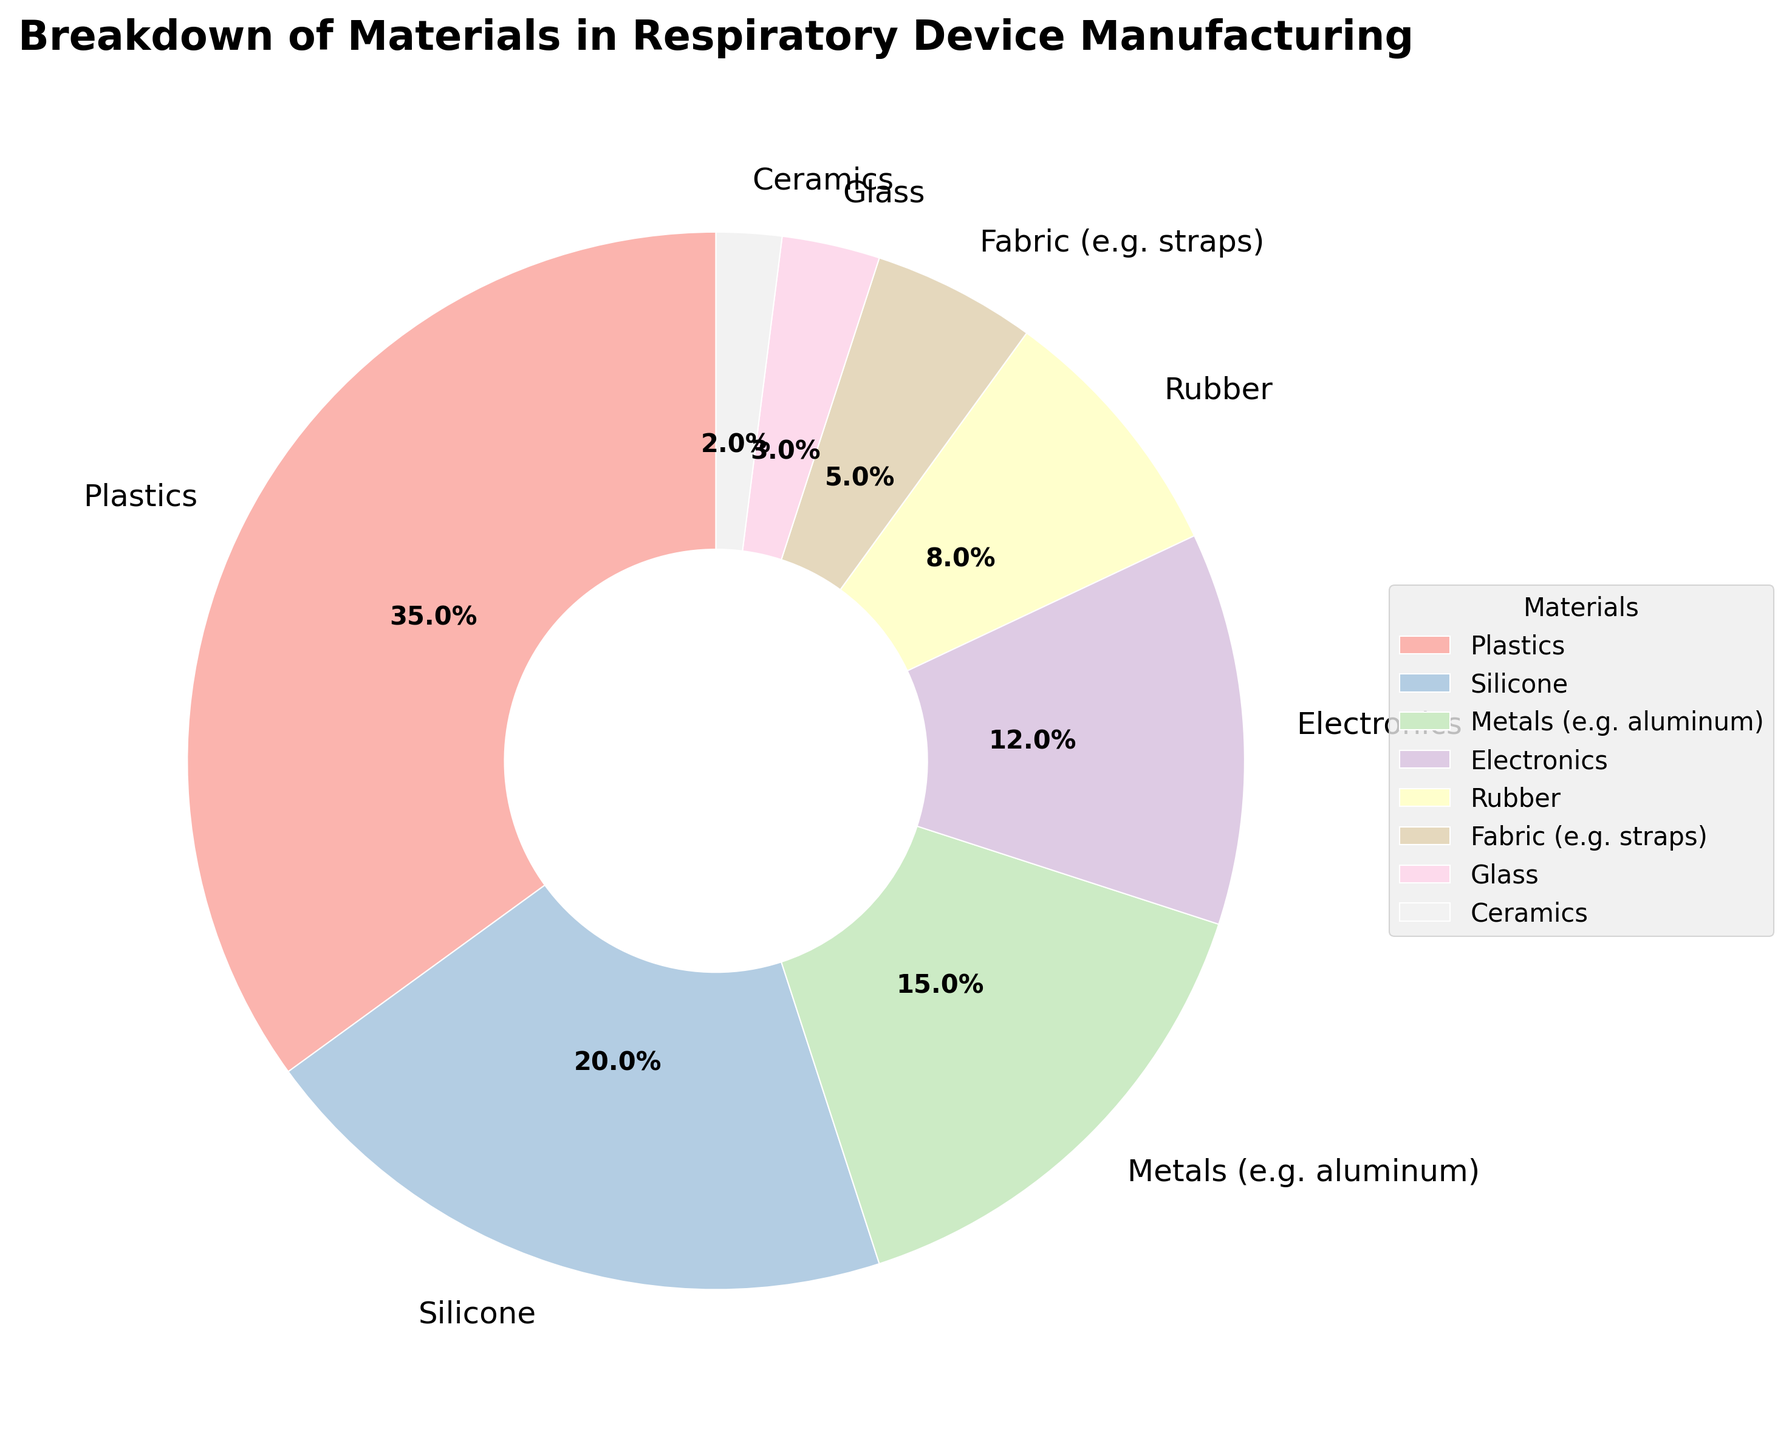Which material is used the most for respiratory device manufacturing? The material with the highest percentage is used the most. From the figure, Plastics has the highest percentage.
Answer: Plastics Which material is used the least for respiratory device manufacturing? The material with the lowest percentage is used the least. From the figure, Ceramics has the lowest percentage.
Answer: Ceramics What is the combined percentage of Plastics and Silicone? Add the percentages of Plastics and Silicone. According to the figure, Plastics is 35% and Silicone is 20%, so 35 + 20 = 55%.
Answer: 55% How much greater is the percentage of Metals compared to Fabric? Subtract the percentage of Fabric from the percentage of Metals. According to the figure, Metals is 15% and Fabric is 5%, so 15 - 5 = 10%.
Answer: 10% Are Electronics used more than Rubber? Compare the percentages of Electronics and Rubber. According to the figure, Electronics is 12% and Rubber is 8%, so Electronics is used more than Rubber.
Answer: Yes What is the total percentage of materials that have a percentage higher than 10%? Sum the percentages of Plastics, Silicone, and Metals, as these are the only materials above 10%. According to the figure, Plastics is 35%, Silicone is 20%, and Metals is 15%, so 35 + 20 + 15 = 70%.
Answer: 70% How many materials have a percentage of less than 10%? Count the number of materials with a percentage less than 10%. According to the figure, there are Rubber (8%), Fabric (5%), Glass (3%), and Ceramics (2%), totaling 4 materials.
Answer: 4 Which material has a percentage closest to the percentage of Electronics? Look for the material with a percentage nearest to 12%, the percentage of Electronics. According to the figure, Metals has 15%, which is the closest.
Answer: Metals Is the combined percentage of Fabric and Glass greater than the percentage of Rubber? Add the percentages of Fabric and Glass, then compare it to the percentage of Rubber. According to the figure, Fabric is 5% and Glass is 3%, so 5 + 3 = 8%. Rubber is also 8%, so the combined percentage equals the percentage of Rubber.
Answer: No, they are equal If the percentages of all materials are doubled, what would be the new percentage for Silicone? Double the original percentage of Silicone. According to the figure, Silicone is 20%, so doubling it would be 20 * 2 = 40%.
Answer: 40% 